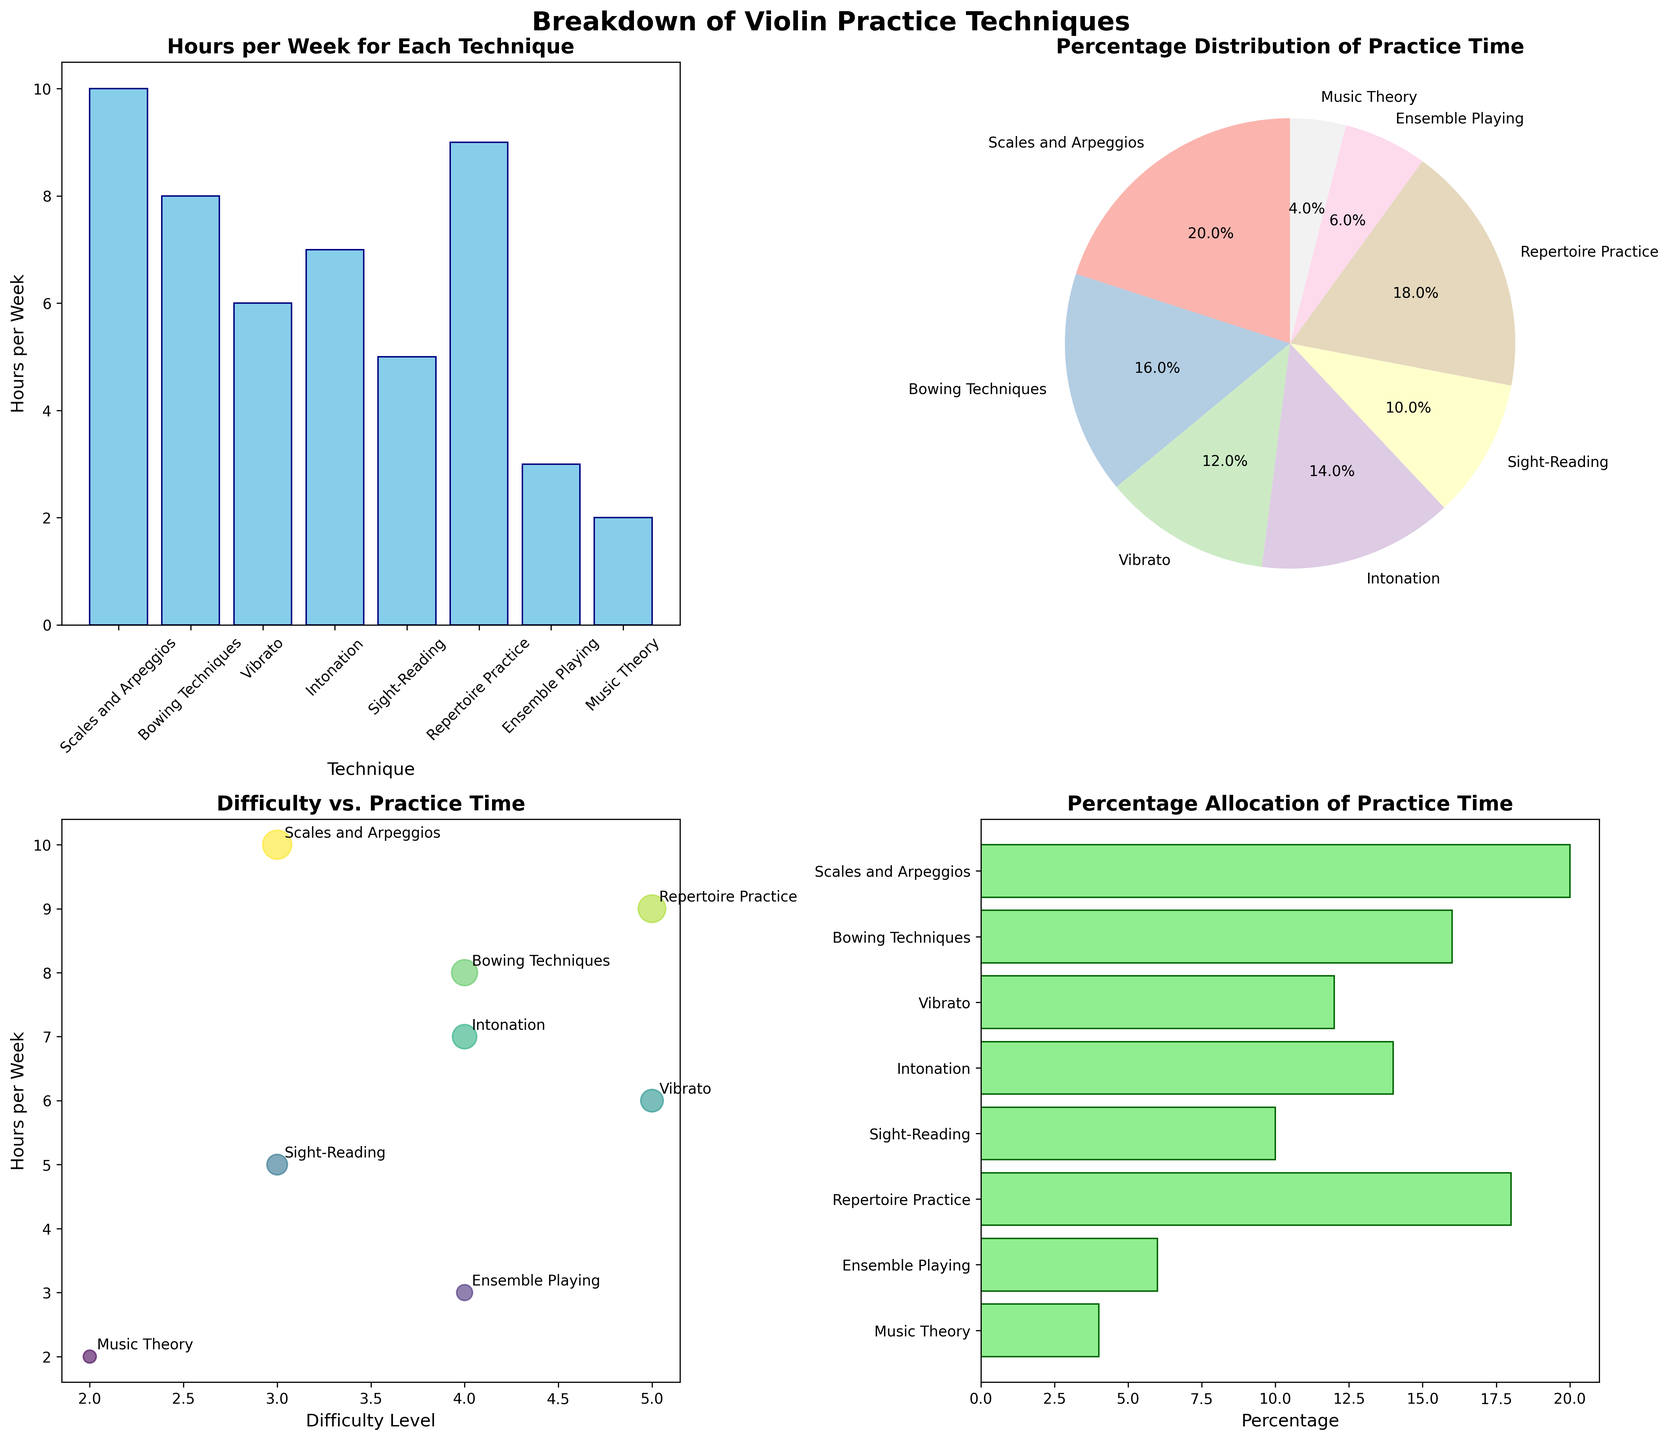what is the total number of hours spent on practice per week? Sum the hours per week for each technique: 10 (Scales and Arpeggios) + 8 (Bowing Techniques) + 6 (Vibrato) + 7 (Intonation) + 5 (Sight-Reading) + 9 (Repertoire Practice) + 3 (Ensemble Playing) + 2 (Music Theory) = 50 hours
Answer: 50 Which technique has the highest percentage allocation of practice time? Look at both the pie chart and horizontal bar chart to identify the segment or bar with the highest percentage: Repertoire Practice has the highest percentage of 18%.
Answer: Repertoire Practice How many techniques have a difficulty level of 4? Observe the scatter plot where the difficulty level is plotted on the x-axis and count the number of data points at the level of 4: Bowing Techniques, Intonation, and Ensemble Playing.
Answer: 3 Which technique has the lowest number of hours per week? Refer to the bar plot and find the shortest bar: Music Theory has the lowest with 2 hours per week.
Answer: Music Theory What is the combined percentage of practice time for Scales and Arpeggios and Bowing Techniques? Add their respective percentages from either the pie chart or horizontal bar chart: 20% (Scales and Arpeggios) + 16% (Bowing Techniques) = 36%.
Answer: 36% How does the practice time for Intonation compare to Vibrato? Compare the bars for each in the bar plot: Intonation has 7 hours while Vibrato has 6 hours. Thus, Intonation has 1 hour more than Vibrato.
Answer: Intonation has 1 more hour than Vibrato Which technique has the highest difficulty level and how many hours are allotted to it? Check the scatter plot for the highest difficulty level and note the technique and its corresponding hours: Vibrato has the highest difficulty level of 5 with 6 hours per week.
Answer: Vibrato with 6 hours per week What is the average number of hours spent on techniques with a difficulty level of 3? Only Scales and Arpeggios (10 hours) and Sight-Reading (5 hours) have a difficulty level of 3. Sum these hours and divide by 2: (10 + 5) / 2 = 7.5 hours.
Answer: 7.5 hours Which technique is represented by the largest bubble in the scatter plot? In the scatter plot, the size of the bubble correlates with the percentage of practice time. Repertoire Practice, which has the largest percentage (18%), would be the largest bubble.
Answer: Repertoire Practice 